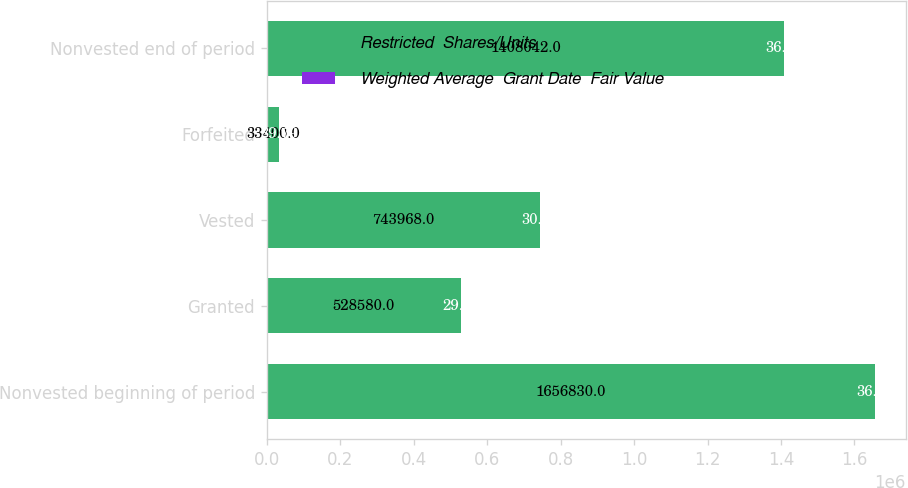<chart> <loc_0><loc_0><loc_500><loc_500><stacked_bar_chart><ecel><fcel>Nonvested beginning of period<fcel>Granted<fcel>Vested<fcel>Forfeited<fcel>Nonvested end of period<nl><fcel>Restricted  Shares/Units<fcel>1.65683e+06<fcel>528580<fcel>743968<fcel>33400<fcel>1.40804e+06<nl><fcel>Weighted Average  Grant Date  Fair Value<fcel>36.56<fcel>29.07<fcel>30.23<fcel>39.79<fcel>36.97<nl></chart> 